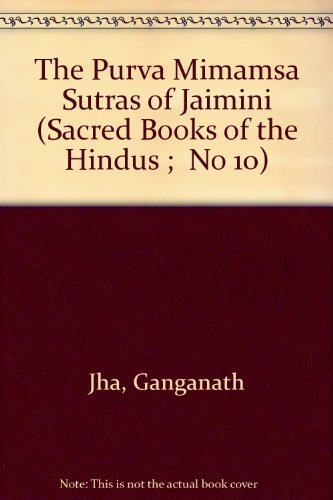What is the title of this book? The full title of the book displayed is 'The Purva Mimamsa Sutras of Jaimini (Sacred Books of the Hindus; No 10)', a detailed exposition of one of the six systems of Indian philosophy. 